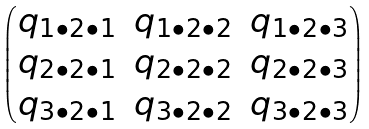Convert formula to latex. <formula><loc_0><loc_0><loc_500><loc_500>\begin{pmatrix} q _ { 1 \bullet 2 \bullet 1 } & q _ { 1 \bullet 2 \bullet 2 } & q _ { 1 \bullet 2 \bullet 3 } \\ q _ { 2 \bullet 2 \bullet 1 } & q _ { 2 \bullet 2 \bullet 2 } & q _ { 2 \bullet 2 \bullet 3 } \\ q _ { 3 \bullet 2 \bullet 1 } & q _ { 3 \bullet 2 \bullet 2 } & q _ { 3 \bullet 2 \bullet 3 } \\ \end{pmatrix}</formula> 